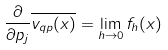<formula> <loc_0><loc_0><loc_500><loc_500>\frac { \partial } { \partial p _ { j } } \overline { v _ { q p } ( x ) } = \lim _ { h \rightarrow 0 } f _ { h } ( x )</formula> 